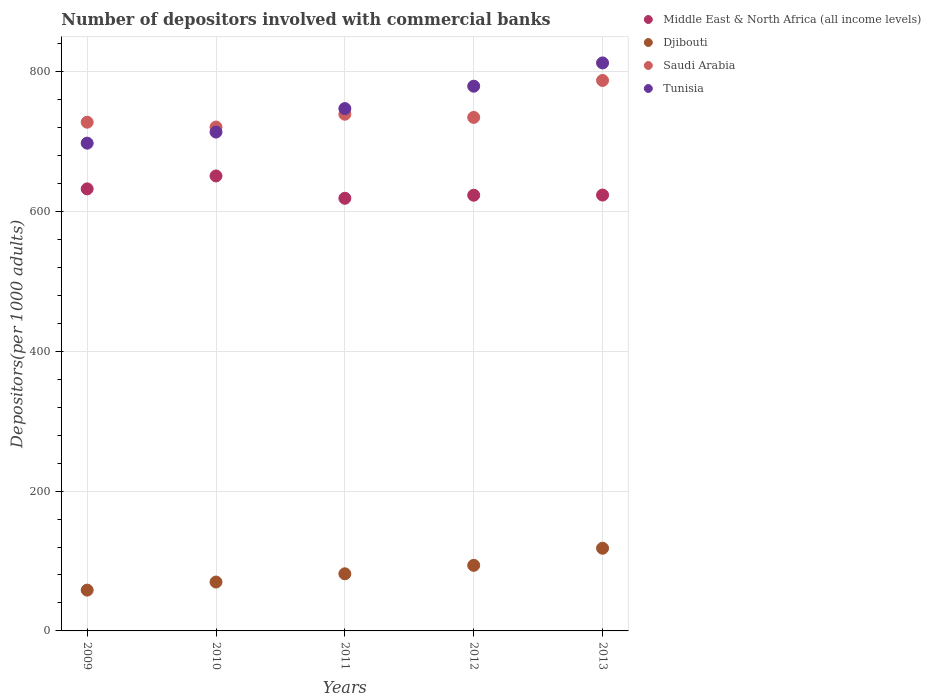How many different coloured dotlines are there?
Provide a succinct answer. 4. What is the number of depositors involved with commercial banks in Saudi Arabia in 2011?
Provide a succinct answer. 739.05. Across all years, what is the maximum number of depositors involved with commercial banks in Middle East & North Africa (all income levels)?
Keep it short and to the point. 650.77. Across all years, what is the minimum number of depositors involved with commercial banks in Saudi Arabia?
Ensure brevity in your answer.  720.71. In which year was the number of depositors involved with commercial banks in Middle East & North Africa (all income levels) minimum?
Your answer should be very brief. 2011. What is the total number of depositors involved with commercial banks in Middle East & North Africa (all income levels) in the graph?
Your answer should be very brief. 3148.57. What is the difference between the number of depositors involved with commercial banks in Djibouti in 2009 and that in 2013?
Provide a short and direct response. -59.88. What is the difference between the number of depositors involved with commercial banks in Tunisia in 2011 and the number of depositors involved with commercial banks in Saudi Arabia in 2012?
Make the answer very short. 12.62. What is the average number of depositors involved with commercial banks in Middle East & North Africa (all income levels) per year?
Ensure brevity in your answer.  629.71. In the year 2012, what is the difference between the number of depositors involved with commercial banks in Djibouti and number of depositors involved with commercial banks in Saudi Arabia?
Make the answer very short. -640.72. In how many years, is the number of depositors involved with commercial banks in Djibouti greater than 680?
Provide a succinct answer. 0. What is the ratio of the number of depositors involved with commercial banks in Tunisia in 2009 to that in 2012?
Your answer should be very brief. 0.9. Is the number of depositors involved with commercial banks in Middle East & North Africa (all income levels) in 2009 less than that in 2013?
Your answer should be very brief. No. What is the difference between the highest and the second highest number of depositors involved with commercial banks in Djibouti?
Provide a succinct answer. 24.46. What is the difference between the highest and the lowest number of depositors involved with commercial banks in Djibouti?
Give a very brief answer. 59.88. In how many years, is the number of depositors involved with commercial banks in Tunisia greater than the average number of depositors involved with commercial banks in Tunisia taken over all years?
Give a very brief answer. 2. Is it the case that in every year, the sum of the number of depositors involved with commercial banks in Tunisia and number of depositors involved with commercial banks in Saudi Arabia  is greater than the sum of number of depositors involved with commercial banks in Djibouti and number of depositors involved with commercial banks in Middle East & North Africa (all income levels)?
Ensure brevity in your answer.  No. Is it the case that in every year, the sum of the number of depositors involved with commercial banks in Middle East & North Africa (all income levels) and number of depositors involved with commercial banks in Tunisia  is greater than the number of depositors involved with commercial banks in Saudi Arabia?
Offer a terse response. Yes. How many dotlines are there?
Offer a very short reply. 4. Are the values on the major ticks of Y-axis written in scientific E-notation?
Give a very brief answer. No. Where does the legend appear in the graph?
Your answer should be very brief. Top right. What is the title of the graph?
Your answer should be very brief. Number of depositors involved with commercial banks. Does "Upper middle income" appear as one of the legend labels in the graph?
Provide a short and direct response. No. What is the label or title of the Y-axis?
Provide a succinct answer. Depositors(per 1000 adults). What is the Depositors(per 1000 adults) in Middle East & North Africa (all income levels) in 2009?
Your answer should be compact. 632.29. What is the Depositors(per 1000 adults) of Djibouti in 2009?
Make the answer very short. 58.37. What is the Depositors(per 1000 adults) in Saudi Arabia in 2009?
Offer a very short reply. 727.65. What is the Depositors(per 1000 adults) in Tunisia in 2009?
Your answer should be compact. 697.68. What is the Depositors(per 1000 adults) of Middle East & North Africa (all income levels) in 2010?
Ensure brevity in your answer.  650.77. What is the Depositors(per 1000 adults) of Djibouti in 2010?
Offer a very short reply. 69.91. What is the Depositors(per 1000 adults) of Saudi Arabia in 2010?
Offer a terse response. 720.71. What is the Depositors(per 1000 adults) of Tunisia in 2010?
Your answer should be very brief. 713.56. What is the Depositors(per 1000 adults) in Middle East & North Africa (all income levels) in 2011?
Ensure brevity in your answer.  618.84. What is the Depositors(per 1000 adults) in Djibouti in 2011?
Provide a short and direct response. 81.7. What is the Depositors(per 1000 adults) of Saudi Arabia in 2011?
Your response must be concise. 739.05. What is the Depositors(per 1000 adults) of Tunisia in 2011?
Your response must be concise. 747.13. What is the Depositors(per 1000 adults) of Middle East & North Africa (all income levels) in 2012?
Make the answer very short. 623.22. What is the Depositors(per 1000 adults) of Djibouti in 2012?
Give a very brief answer. 93.79. What is the Depositors(per 1000 adults) of Saudi Arabia in 2012?
Your answer should be compact. 734.51. What is the Depositors(per 1000 adults) of Tunisia in 2012?
Ensure brevity in your answer.  779.16. What is the Depositors(per 1000 adults) in Middle East & North Africa (all income levels) in 2013?
Your response must be concise. 623.45. What is the Depositors(per 1000 adults) in Djibouti in 2013?
Offer a terse response. 118.26. What is the Depositors(per 1000 adults) of Saudi Arabia in 2013?
Offer a terse response. 787.36. What is the Depositors(per 1000 adults) in Tunisia in 2013?
Your answer should be very brief. 812.43. Across all years, what is the maximum Depositors(per 1000 adults) in Middle East & North Africa (all income levels)?
Your response must be concise. 650.77. Across all years, what is the maximum Depositors(per 1000 adults) in Djibouti?
Your response must be concise. 118.26. Across all years, what is the maximum Depositors(per 1000 adults) of Saudi Arabia?
Ensure brevity in your answer.  787.36. Across all years, what is the maximum Depositors(per 1000 adults) in Tunisia?
Your answer should be compact. 812.43. Across all years, what is the minimum Depositors(per 1000 adults) of Middle East & North Africa (all income levels)?
Your answer should be very brief. 618.84. Across all years, what is the minimum Depositors(per 1000 adults) in Djibouti?
Ensure brevity in your answer.  58.37. Across all years, what is the minimum Depositors(per 1000 adults) of Saudi Arabia?
Give a very brief answer. 720.71. Across all years, what is the minimum Depositors(per 1000 adults) in Tunisia?
Offer a terse response. 697.68. What is the total Depositors(per 1000 adults) of Middle East & North Africa (all income levels) in the graph?
Give a very brief answer. 3148.57. What is the total Depositors(per 1000 adults) of Djibouti in the graph?
Your answer should be compact. 422.04. What is the total Depositors(per 1000 adults) in Saudi Arabia in the graph?
Offer a terse response. 3709.27. What is the total Depositors(per 1000 adults) in Tunisia in the graph?
Offer a very short reply. 3749.95. What is the difference between the Depositors(per 1000 adults) in Middle East & North Africa (all income levels) in 2009 and that in 2010?
Offer a terse response. -18.47. What is the difference between the Depositors(per 1000 adults) in Djibouti in 2009 and that in 2010?
Keep it short and to the point. -11.54. What is the difference between the Depositors(per 1000 adults) in Saudi Arabia in 2009 and that in 2010?
Make the answer very short. 6.93. What is the difference between the Depositors(per 1000 adults) of Tunisia in 2009 and that in 2010?
Offer a very short reply. -15.88. What is the difference between the Depositors(per 1000 adults) of Middle East & North Africa (all income levels) in 2009 and that in 2011?
Offer a very short reply. 13.45. What is the difference between the Depositors(per 1000 adults) of Djibouti in 2009 and that in 2011?
Make the answer very short. -23.33. What is the difference between the Depositors(per 1000 adults) in Saudi Arabia in 2009 and that in 2011?
Ensure brevity in your answer.  -11.4. What is the difference between the Depositors(per 1000 adults) of Tunisia in 2009 and that in 2011?
Ensure brevity in your answer.  -49.45. What is the difference between the Depositors(per 1000 adults) in Middle East & North Africa (all income levels) in 2009 and that in 2012?
Your answer should be compact. 9.07. What is the difference between the Depositors(per 1000 adults) in Djibouti in 2009 and that in 2012?
Offer a terse response. -35.42. What is the difference between the Depositors(per 1000 adults) of Saudi Arabia in 2009 and that in 2012?
Your response must be concise. -6.87. What is the difference between the Depositors(per 1000 adults) in Tunisia in 2009 and that in 2012?
Provide a succinct answer. -81.49. What is the difference between the Depositors(per 1000 adults) of Middle East & North Africa (all income levels) in 2009 and that in 2013?
Provide a short and direct response. 8.85. What is the difference between the Depositors(per 1000 adults) of Djibouti in 2009 and that in 2013?
Ensure brevity in your answer.  -59.88. What is the difference between the Depositors(per 1000 adults) of Saudi Arabia in 2009 and that in 2013?
Your answer should be very brief. -59.71. What is the difference between the Depositors(per 1000 adults) of Tunisia in 2009 and that in 2013?
Ensure brevity in your answer.  -114.75. What is the difference between the Depositors(per 1000 adults) in Middle East & North Africa (all income levels) in 2010 and that in 2011?
Provide a succinct answer. 31.92. What is the difference between the Depositors(per 1000 adults) in Djibouti in 2010 and that in 2011?
Offer a very short reply. -11.79. What is the difference between the Depositors(per 1000 adults) of Saudi Arabia in 2010 and that in 2011?
Keep it short and to the point. -18.33. What is the difference between the Depositors(per 1000 adults) in Tunisia in 2010 and that in 2011?
Provide a short and direct response. -33.57. What is the difference between the Depositors(per 1000 adults) of Middle East & North Africa (all income levels) in 2010 and that in 2012?
Provide a succinct answer. 27.55. What is the difference between the Depositors(per 1000 adults) in Djibouti in 2010 and that in 2012?
Provide a short and direct response. -23.88. What is the difference between the Depositors(per 1000 adults) in Saudi Arabia in 2010 and that in 2012?
Provide a short and direct response. -13.8. What is the difference between the Depositors(per 1000 adults) in Tunisia in 2010 and that in 2012?
Your answer should be compact. -65.61. What is the difference between the Depositors(per 1000 adults) of Middle East & North Africa (all income levels) in 2010 and that in 2013?
Offer a very short reply. 27.32. What is the difference between the Depositors(per 1000 adults) of Djibouti in 2010 and that in 2013?
Your response must be concise. -48.35. What is the difference between the Depositors(per 1000 adults) in Saudi Arabia in 2010 and that in 2013?
Give a very brief answer. -66.64. What is the difference between the Depositors(per 1000 adults) of Tunisia in 2010 and that in 2013?
Provide a short and direct response. -98.87. What is the difference between the Depositors(per 1000 adults) of Middle East & North Africa (all income levels) in 2011 and that in 2012?
Offer a very short reply. -4.38. What is the difference between the Depositors(per 1000 adults) of Djibouti in 2011 and that in 2012?
Offer a terse response. -12.09. What is the difference between the Depositors(per 1000 adults) of Saudi Arabia in 2011 and that in 2012?
Ensure brevity in your answer.  4.54. What is the difference between the Depositors(per 1000 adults) in Tunisia in 2011 and that in 2012?
Offer a very short reply. -32.03. What is the difference between the Depositors(per 1000 adults) of Middle East & North Africa (all income levels) in 2011 and that in 2013?
Keep it short and to the point. -4.61. What is the difference between the Depositors(per 1000 adults) in Djibouti in 2011 and that in 2013?
Give a very brief answer. -36.55. What is the difference between the Depositors(per 1000 adults) in Saudi Arabia in 2011 and that in 2013?
Provide a short and direct response. -48.31. What is the difference between the Depositors(per 1000 adults) of Tunisia in 2011 and that in 2013?
Ensure brevity in your answer.  -65.3. What is the difference between the Depositors(per 1000 adults) in Middle East & North Africa (all income levels) in 2012 and that in 2013?
Offer a very short reply. -0.23. What is the difference between the Depositors(per 1000 adults) of Djibouti in 2012 and that in 2013?
Keep it short and to the point. -24.46. What is the difference between the Depositors(per 1000 adults) of Saudi Arabia in 2012 and that in 2013?
Ensure brevity in your answer.  -52.85. What is the difference between the Depositors(per 1000 adults) in Tunisia in 2012 and that in 2013?
Your response must be concise. -33.26. What is the difference between the Depositors(per 1000 adults) of Middle East & North Africa (all income levels) in 2009 and the Depositors(per 1000 adults) of Djibouti in 2010?
Ensure brevity in your answer.  562.38. What is the difference between the Depositors(per 1000 adults) in Middle East & North Africa (all income levels) in 2009 and the Depositors(per 1000 adults) in Saudi Arabia in 2010?
Ensure brevity in your answer.  -88.42. What is the difference between the Depositors(per 1000 adults) of Middle East & North Africa (all income levels) in 2009 and the Depositors(per 1000 adults) of Tunisia in 2010?
Ensure brevity in your answer.  -81.26. What is the difference between the Depositors(per 1000 adults) of Djibouti in 2009 and the Depositors(per 1000 adults) of Saudi Arabia in 2010?
Offer a terse response. -662.34. What is the difference between the Depositors(per 1000 adults) in Djibouti in 2009 and the Depositors(per 1000 adults) in Tunisia in 2010?
Make the answer very short. -655.18. What is the difference between the Depositors(per 1000 adults) of Saudi Arabia in 2009 and the Depositors(per 1000 adults) of Tunisia in 2010?
Your answer should be very brief. 14.09. What is the difference between the Depositors(per 1000 adults) in Middle East & North Africa (all income levels) in 2009 and the Depositors(per 1000 adults) in Djibouti in 2011?
Offer a very short reply. 550.59. What is the difference between the Depositors(per 1000 adults) of Middle East & North Africa (all income levels) in 2009 and the Depositors(per 1000 adults) of Saudi Arabia in 2011?
Offer a very short reply. -106.75. What is the difference between the Depositors(per 1000 adults) in Middle East & North Africa (all income levels) in 2009 and the Depositors(per 1000 adults) in Tunisia in 2011?
Offer a terse response. -114.84. What is the difference between the Depositors(per 1000 adults) in Djibouti in 2009 and the Depositors(per 1000 adults) in Saudi Arabia in 2011?
Ensure brevity in your answer.  -680.67. What is the difference between the Depositors(per 1000 adults) in Djibouti in 2009 and the Depositors(per 1000 adults) in Tunisia in 2011?
Ensure brevity in your answer.  -688.75. What is the difference between the Depositors(per 1000 adults) in Saudi Arabia in 2009 and the Depositors(per 1000 adults) in Tunisia in 2011?
Your response must be concise. -19.48. What is the difference between the Depositors(per 1000 adults) of Middle East & North Africa (all income levels) in 2009 and the Depositors(per 1000 adults) of Djibouti in 2012?
Provide a short and direct response. 538.5. What is the difference between the Depositors(per 1000 adults) in Middle East & North Africa (all income levels) in 2009 and the Depositors(per 1000 adults) in Saudi Arabia in 2012?
Your answer should be very brief. -102.22. What is the difference between the Depositors(per 1000 adults) of Middle East & North Africa (all income levels) in 2009 and the Depositors(per 1000 adults) of Tunisia in 2012?
Offer a terse response. -146.87. What is the difference between the Depositors(per 1000 adults) of Djibouti in 2009 and the Depositors(per 1000 adults) of Saudi Arabia in 2012?
Give a very brief answer. -676.14. What is the difference between the Depositors(per 1000 adults) in Djibouti in 2009 and the Depositors(per 1000 adults) in Tunisia in 2012?
Give a very brief answer. -720.79. What is the difference between the Depositors(per 1000 adults) of Saudi Arabia in 2009 and the Depositors(per 1000 adults) of Tunisia in 2012?
Keep it short and to the point. -51.52. What is the difference between the Depositors(per 1000 adults) of Middle East & North Africa (all income levels) in 2009 and the Depositors(per 1000 adults) of Djibouti in 2013?
Provide a short and direct response. 514.04. What is the difference between the Depositors(per 1000 adults) in Middle East & North Africa (all income levels) in 2009 and the Depositors(per 1000 adults) in Saudi Arabia in 2013?
Your answer should be very brief. -155.06. What is the difference between the Depositors(per 1000 adults) in Middle East & North Africa (all income levels) in 2009 and the Depositors(per 1000 adults) in Tunisia in 2013?
Your response must be concise. -180.13. What is the difference between the Depositors(per 1000 adults) in Djibouti in 2009 and the Depositors(per 1000 adults) in Saudi Arabia in 2013?
Provide a succinct answer. -728.98. What is the difference between the Depositors(per 1000 adults) of Djibouti in 2009 and the Depositors(per 1000 adults) of Tunisia in 2013?
Your response must be concise. -754.05. What is the difference between the Depositors(per 1000 adults) of Saudi Arabia in 2009 and the Depositors(per 1000 adults) of Tunisia in 2013?
Make the answer very short. -84.78. What is the difference between the Depositors(per 1000 adults) of Middle East & North Africa (all income levels) in 2010 and the Depositors(per 1000 adults) of Djibouti in 2011?
Offer a very short reply. 569.07. What is the difference between the Depositors(per 1000 adults) of Middle East & North Africa (all income levels) in 2010 and the Depositors(per 1000 adults) of Saudi Arabia in 2011?
Your response must be concise. -88.28. What is the difference between the Depositors(per 1000 adults) in Middle East & North Africa (all income levels) in 2010 and the Depositors(per 1000 adults) in Tunisia in 2011?
Provide a succinct answer. -96.36. What is the difference between the Depositors(per 1000 adults) of Djibouti in 2010 and the Depositors(per 1000 adults) of Saudi Arabia in 2011?
Provide a succinct answer. -669.14. What is the difference between the Depositors(per 1000 adults) in Djibouti in 2010 and the Depositors(per 1000 adults) in Tunisia in 2011?
Your response must be concise. -677.22. What is the difference between the Depositors(per 1000 adults) of Saudi Arabia in 2010 and the Depositors(per 1000 adults) of Tunisia in 2011?
Provide a succinct answer. -26.42. What is the difference between the Depositors(per 1000 adults) in Middle East & North Africa (all income levels) in 2010 and the Depositors(per 1000 adults) in Djibouti in 2012?
Provide a short and direct response. 556.97. What is the difference between the Depositors(per 1000 adults) of Middle East & North Africa (all income levels) in 2010 and the Depositors(per 1000 adults) of Saudi Arabia in 2012?
Provide a short and direct response. -83.74. What is the difference between the Depositors(per 1000 adults) in Middle East & North Africa (all income levels) in 2010 and the Depositors(per 1000 adults) in Tunisia in 2012?
Offer a terse response. -128.4. What is the difference between the Depositors(per 1000 adults) of Djibouti in 2010 and the Depositors(per 1000 adults) of Saudi Arabia in 2012?
Your answer should be compact. -664.6. What is the difference between the Depositors(per 1000 adults) of Djibouti in 2010 and the Depositors(per 1000 adults) of Tunisia in 2012?
Your response must be concise. -709.25. What is the difference between the Depositors(per 1000 adults) of Saudi Arabia in 2010 and the Depositors(per 1000 adults) of Tunisia in 2012?
Give a very brief answer. -58.45. What is the difference between the Depositors(per 1000 adults) of Middle East & North Africa (all income levels) in 2010 and the Depositors(per 1000 adults) of Djibouti in 2013?
Your response must be concise. 532.51. What is the difference between the Depositors(per 1000 adults) of Middle East & North Africa (all income levels) in 2010 and the Depositors(per 1000 adults) of Saudi Arabia in 2013?
Your answer should be compact. -136.59. What is the difference between the Depositors(per 1000 adults) in Middle East & North Africa (all income levels) in 2010 and the Depositors(per 1000 adults) in Tunisia in 2013?
Offer a very short reply. -161.66. What is the difference between the Depositors(per 1000 adults) in Djibouti in 2010 and the Depositors(per 1000 adults) in Saudi Arabia in 2013?
Make the answer very short. -717.45. What is the difference between the Depositors(per 1000 adults) of Djibouti in 2010 and the Depositors(per 1000 adults) of Tunisia in 2013?
Your answer should be very brief. -742.52. What is the difference between the Depositors(per 1000 adults) of Saudi Arabia in 2010 and the Depositors(per 1000 adults) of Tunisia in 2013?
Your answer should be compact. -91.71. What is the difference between the Depositors(per 1000 adults) in Middle East & North Africa (all income levels) in 2011 and the Depositors(per 1000 adults) in Djibouti in 2012?
Make the answer very short. 525.05. What is the difference between the Depositors(per 1000 adults) of Middle East & North Africa (all income levels) in 2011 and the Depositors(per 1000 adults) of Saudi Arabia in 2012?
Provide a short and direct response. -115.67. What is the difference between the Depositors(per 1000 adults) of Middle East & North Africa (all income levels) in 2011 and the Depositors(per 1000 adults) of Tunisia in 2012?
Your answer should be compact. -160.32. What is the difference between the Depositors(per 1000 adults) in Djibouti in 2011 and the Depositors(per 1000 adults) in Saudi Arabia in 2012?
Provide a short and direct response. -652.81. What is the difference between the Depositors(per 1000 adults) of Djibouti in 2011 and the Depositors(per 1000 adults) of Tunisia in 2012?
Offer a terse response. -697.46. What is the difference between the Depositors(per 1000 adults) of Saudi Arabia in 2011 and the Depositors(per 1000 adults) of Tunisia in 2012?
Your answer should be compact. -40.12. What is the difference between the Depositors(per 1000 adults) of Middle East & North Africa (all income levels) in 2011 and the Depositors(per 1000 adults) of Djibouti in 2013?
Offer a terse response. 500.59. What is the difference between the Depositors(per 1000 adults) of Middle East & North Africa (all income levels) in 2011 and the Depositors(per 1000 adults) of Saudi Arabia in 2013?
Your answer should be very brief. -168.51. What is the difference between the Depositors(per 1000 adults) in Middle East & North Africa (all income levels) in 2011 and the Depositors(per 1000 adults) in Tunisia in 2013?
Your answer should be compact. -193.58. What is the difference between the Depositors(per 1000 adults) in Djibouti in 2011 and the Depositors(per 1000 adults) in Saudi Arabia in 2013?
Your response must be concise. -705.65. What is the difference between the Depositors(per 1000 adults) in Djibouti in 2011 and the Depositors(per 1000 adults) in Tunisia in 2013?
Provide a short and direct response. -730.72. What is the difference between the Depositors(per 1000 adults) in Saudi Arabia in 2011 and the Depositors(per 1000 adults) in Tunisia in 2013?
Offer a very short reply. -73.38. What is the difference between the Depositors(per 1000 adults) in Middle East & North Africa (all income levels) in 2012 and the Depositors(per 1000 adults) in Djibouti in 2013?
Give a very brief answer. 504.97. What is the difference between the Depositors(per 1000 adults) of Middle East & North Africa (all income levels) in 2012 and the Depositors(per 1000 adults) of Saudi Arabia in 2013?
Offer a very short reply. -164.13. What is the difference between the Depositors(per 1000 adults) in Middle East & North Africa (all income levels) in 2012 and the Depositors(per 1000 adults) in Tunisia in 2013?
Ensure brevity in your answer.  -189.2. What is the difference between the Depositors(per 1000 adults) in Djibouti in 2012 and the Depositors(per 1000 adults) in Saudi Arabia in 2013?
Offer a terse response. -693.56. What is the difference between the Depositors(per 1000 adults) of Djibouti in 2012 and the Depositors(per 1000 adults) of Tunisia in 2013?
Ensure brevity in your answer.  -718.63. What is the difference between the Depositors(per 1000 adults) of Saudi Arabia in 2012 and the Depositors(per 1000 adults) of Tunisia in 2013?
Provide a succinct answer. -77.91. What is the average Depositors(per 1000 adults) of Middle East & North Africa (all income levels) per year?
Your answer should be compact. 629.71. What is the average Depositors(per 1000 adults) of Djibouti per year?
Your response must be concise. 84.41. What is the average Depositors(per 1000 adults) in Saudi Arabia per year?
Keep it short and to the point. 741.85. What is the average Depositors(per 1000 adults) of Tunisia per year?
Ensure brevity in your answer.  749.99. In the year 2009, what is the difference between the Depositors(per 1000 adults) in Middle East & North Africa (all income levels) and Depositors(per 1000 adults) in Djibouti?
Keep it short and to the point. 573.92. In the year 2009, what is the difference between the Depositors(per 1000 adults) in Middle East & North Africa (all income levels) and Depositors(per 1000 adults) in Saudi Arabia?
Offer a terse response. -95.35. In the year 2009, what is the difference between the Depositors(per 1000 adults) of Middle East & North Africa (all income levels) and Depositors(per 1000 adults) of Tunisia?
Give a very brief answer. -65.38. In the year 2009, what is the difference between the Depositors(per 1000 adults) of Djibouti and Depositors(per 1000 adults) of Saudi Arabia?
Your answer should be compact. -669.27. In the year 2009, what is the difference between the Depositors(per 1000 adults) in Djibouti and Depositors(per 1000 adults) in Tunisia?
Provide a succinct answer. -639.3. In the year 2009, what is the difference between the Depositors(per 1000 adults) of Saudi Arabia and Depositors(per 1000 adults) of Tunisia?
Your answer should be very brief. 29.97. In the year 2010, what is the difference between the Depositors(per 1000 adults) of Middle East & North Africa (all income levels) and Depositors(per 1000 adults) of Djibouti?
Provide a short and direct response. 580.86. In the year 2010, what is the difference between the Depositors(per 1000 adults) in Middle East & North Africa (all income levels) and Depositors(per 1000 adults) in Saudi Arabia?
Offer a terse response. -69.95. In the year 2010, what is the difference between the Depositors(per 1000 adults) of Middle East & North Africa (all income levels) and Depositors(per 1000 adults) of Tunisia?
Make the answer very short. -62.79. In the year 2010, what is the difference between the Depositors(per 1000 adults) of Djibouti and Depositors(per 1000 adults) of Saudi Arabia?
Ensure brevity in your answer.  -650.8. In the year 2010, what is the difference between the Depositors(per 1000 adults) in Djibouti and Depositors(per 1000 adults) in Tunisia?
Give a very brief answer. -643.65. In the year 2010, what is the difference between the Depositors(per 1000 adults) in Saudi Arabia and Depositors(per 1000 adults) in Tunisia?
Your answer should be very brief. 7.16. In the year 2011, what is the difference between the Depositors(per 1000 adults) of Middle East & North Africa (all income levels) and Depositors(per 1000 adults) of Djibouti?
Provide a short and direct response. 537.14. In the year 2011, what is the difference between the Depositors(per 1000 adults) in Middle East & North Africa (all income levels) and Depositors(per 1000 adults) in Saudi Arabia?
Make the answer very short. -120.2. In the year 2011, what is the difference between the Depositors(per 1000 adults) of Middle East & North Africa (all income levels) and Depositors(per 1000 adults) of Tunisia?
Your response must be concise. -128.29. In the year 2011, what is the difference between the Depositors(per 1000 adults) in Djibouti and Depositors(per 1000 adults) in Saudi Arabia?
Make the answer very short. -657.34. In the year 2011, what is the difference between the Depositors(per 1000 adults) of Djibouti and Depositors(per 1000 adults) of Tunisia?
Provide a short and direct response. -665.43. In the year 2011, what is the difference between the Depositors(per 1000 adults) of Saudi Arabia and Depositors(per 1000 adults) of Tunisia?
Keep it short and to the point. -8.08. In the year 2012, what is the difference between the Depositors(per 1000 adults) of Middle East & North Africa (all income levels) and Depositors(per 1000 adults) of Djibouti?
Provide a short and direct response. 529.43. In the year 2012, what is the difference between the Depositors(per 1000 adults) in Middle East & North Africa (all income levels) and Depositors(per 1000 adults) in Saudi Arabia?
Offer a very short reply. -111.29. In the year 2012, what is the difference between the Depositors(per 1000 adults) of Middle East & North Africa (all income levels) and Depositors(per 1000 adults) of Tunisia?
Give a very brief answer. -155.94. In the year 2012, what is the difference between the Depositors(per 1000 adults) of Djibouti and Depositors(per 1000 adults) of Saudi Arabia?
Keep it short and to the point. -640.72. In the year 2012, what is the difference between the Depositors(per 1000 adults) of Djibouti and Depositors(per 1000 adults) of Tunisia?
Offer a very short reply. -685.37. In the year 2012, what is the difference between the Depositors(per 1000 adults) of Saudi Arabia and Depositors(per 1000 adults) of Tunisia?
Your response must be concise. -44.65. In the year 2013, what is the difference between the Depositors(per 1000 adults) of Middle East & North Africa (all income levels) and Depositors(per 1000 adults) of Djibouti?
Provide a succinct answer. 505.19. In the year 2013, what is the difference between the Depositors(per 1000 adults) of Middle East & North Africa (all income levels) and Depositors(per 1000 adults) of Saudi Arabia?
Offer a very short reply. -163.91. In the year 2013, what is the difference between the Depositors(per 1000 adults) in Middle East & North Africa (all income levels) and Depositors(per 1000 adults) in Tunisia?
Provide a short and direct response. -188.98. In the year 2013, what is the difference between the Depositors(per 1000 adults) in Djibouti and Depositors(per 1000 adults) in Saudi Arabia?
Provide a short and direct response. -669.1. In the year 2013, what is the difference between the Depositors(per 1000 adults) of Djibouti and Depositors(per 1000 adults) of Tunisia?
Your answer should be compact. -694.17. In the year 2013, what is the difference between the Depositors(per 1000 adults) of Saudi Arabia and Depositors(per 1000 adults) of Tunisia?
Offer a very short reply. -25.07. What is the ratio of the Depositors(per 1000 adults) of Middle East & North Africa (all income levels) in 2009 to that in 2010?
Your response must be concise. 0.97. What is the ratio of the Depositors(per 1000 adults) in Djibouti in 2009 to that in 2010?
Give a very brief answer. 0.83. What is the ratio of the Depositors(per 1000 adults) in Saudi Arabia in 2009 to that in 2010?
Provide a succinct answer. 1.01. What is the ratio of the Depositors(per 1000 adults) of Tunisia in 2009 to that in 2010?
Ensure brevity in your answer.  0.98. What is the ratio of the Depositors(per 1000 adults) in Middle East & North Africa (all income levels) in 2009 to that in 2011?
Keep it short and to the point. 1.02. What is the ratio of the Depositors(per 1000 adults) of Djibouti in 2009 to that in 2011?
Keep it short and to the point. 0.71. What is the ratio of the Depositors(per 1000 adults) of Saudi Arabia in 2009 to that in 2011?
Your answer should be very brief. 0.98. What is the ratio of the Depositors(per 1000 adults) of Tunisia in 2009 to that in 2011?
Offer a terse response. 0.93. What is the ratio of the Depositors(per 1000 adults) in Middle East & North Africa (all income levels) in 2009 to that in 2012?
Your answer should be compact. 1.01. What is the ratio of the Depositors(per 1000 adults) of Djibouti in 2009 to that in 2012?
Your answer should be very brief. 0.62. What is the ratio of the Depositors(per 1000 adults) of Saudi Arabia in 2009 to that in 2012?
Offer a terse response. 0.99. What is the ratio of the Depositors(per 1000 adults) in Tunisia in 2009 to that in 2012?
Provide a short and direct response. 0.9. What is the ratio of the Depositors(per 1000 adults) in Middle East & North Africa (all income levels) in 2009 to that in 2013?
Ensure brevity in your answer.  1.01. What is the ratio of the Depositors(per 1000 adults) of Djibouti in 2009 to that in 2013?
Make the answer very short. 0.49. What is the ratio of the Depositors(per 1000 adults) of Saudi Arabia in 2009 to that in 2013?
Ensure brevity in your answer.  0.92. What is the ratio of the Depositors(per 1000 adults) of Tunisia in 2009 to that in 2013?
Your answer should be compact. 0.86. What is the ratio of the Depositors(per 1000 adults) in Middle East & North Africa (all income levels) in 2010 to that in 2011?
Give a very brief answer. 1.05. What is the ratio of the Depositors(per 1000 adults) of Djibouti in 2010 to that in 2011?
Provide a short and direct response. 0.86. What is the ratio of the Depositors(per 1000 adults) in Saudi Arabia in 2010 to that in 2011?
Offer a terse response. 0.98. What is the ratio of the Depositors(per 1000 adults) in Tunisia in 2010 to that in 2011?
Offer a very short reply. 0.96. What is the ratio of the Depositors(per 1000 adults) of Middle East & North Africa (all income levels) in 2010 to that in 2012?
Offer a terse response. 1.04. What is the ratio of the Depositors(per 1000 adults) in Djibouti in 2010 to that in 2012?
Provide a succinct answer. 0.75. What is the ratio of the Depositors(per 1000 adults) of Saudi Arabia in 2010 to that in 2012?
Offer a terse response. 0.98. What is the ratio of the Depositors(per 1000 adults) in Tunisia in 2010 to that in 2012?
Give a very brief answer. 0.92. What is the ratio of the Depositors(per 1000 adults) in Middle East & North Africa (all income levels) in 2010 to that in 2013?
Offer a terse response. 1.04. What is the ratio of the Depositors(per 1000 adults) of Djibouti in 2010 to that in 2013?
Provide a short and direct response. 0.59. What is the ratio of the Depositors(per 1000 adults) of Saudi Arabia in 2010 to that in 2013?
Keep it short and to the point. 0.92. What is the ratio of the Depositors(per 1000 adults) in Tunisia in 2010 to that in 2013?
Give a very brief answer. 0.88. What is the ratio of the Depositors(per 1000 adults) in Middle East & North Africa (all income levels) in 2011 to that in 2012?
Make the answer very short. 0.99. What is the ratio of the Depositors(per 1000 adults) in Djibouti in 2011 to that in 2012?
Offer a terse response. 0.87. What is the ratio of the Depositors(per 1000 adults) in Saudi Arabia in 2011 to that in 2012?
Your answer should be very brief. 1.01. What is the ratio of the Depositors(per 1000 adults) of Tunisia in 2011 to that in 2012?
Provide a succinct answer. 0.96. What is the ratio of the Depositors(per 1000 adults) in Djibouti in 2011 to that in 2013?
Keep it short and to the point. 0.69. What is the ratio of the Depositors(per 1000 adults) in Saudi Arabia in 2011 to that in 2013?
Your response must be concise. 0.94. What is the ratio of the Depositors(per 1000 adults) of Tunisia in 2011 to that in 2013?
Provide a short and direct response. 0.92. What is the ratio of the Depositors(per 1000 adults) in Middle East & North Africa (all income levels) in 2012 to that in 2013?
Give a very brief answer. 1. What is the ratio of the Depositors(per 1000 adults) in Djibouti in 2012 to that in 2013?
Offer a very short reply. 0.79. What is the ratio of the Depositors(per 1000 adults) in Saudi Arabia in 2012 to that in 2013?
Provide a short and direct response. 0.93. What is the ratio of the Depositors(per 1000 adults) of Tunisia in 2012 to that in 2013?
Your answer should be compact. 0.96. What is the difference between the highest and the second highest Depositors(per 1000 adults) of Middle East & North Africa (all income levels)?
Your response must be concise. 18.47. What is the difference between the highest and the second highest Depositors(per 1000 adults) of Djibouti?
Give a very brief answer. 24.46. What is the difference between the highest and the second highest Depositors(per 1000 adults) in Saudi Arabia?
Your response must be concise. 48.31. What is the difference between the highest and the second highest Depositors(per 1000 adults) of Tunisia?
Your response must be concise. 33.26. What is the difference between the highest and the lowest Depositors(per 1000 adults) of Middle East & North Africa (all income levels)?
Keep it short and to the point. 31.92. What is the difference between the highest and the lowest Depositors(per 1000 adults) in Djibouti?
Ensure brevity in your answer.  59.88. What is the difference between the highest and the lowest Depositors(per 1000 adults) of Saudi Arabia?
Provide a short and direct response. 66.64. What is the difference between the highest and the lowest Depositors(per 1000 adults) in Tunisia?
Give a very brief answer. 114.75. 